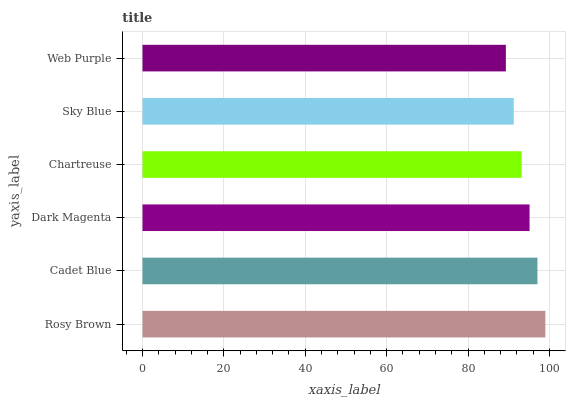Is Web Purple the minimum?
Answer yes or no. Yes. Is Rosy Brown the maximum?
Answer yes or no. Yes. Is Cadet Blue the minimum?
Answer yes or no. No. Is Cadet Blue the maximum?
Answer yes or no. No. Is Rosy Brown greater than Cadet Blue?
Answer yes or no. Yes. Is Cadet Blue less than Rosy Brown?
Answer yes or no. Yes. Is Cadet Blue greater than Rosy Brown?
Answer yes or no. No. Is Rosy Brown less than Cadet Blue?
Answer yes or no. No. Is Dark Magenta the high median?
Answer yes or no. Yes. Is Chartreuse the low median?
Answer yes or no. Yes. Is Chartreuse the high median?
Answer yes or no. No. Is Sky Blue the low median?
Answer yes or no. No. 